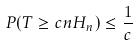<formula> <loc_0><loc_0><loc_500><loc_500>P ( T \geq c n H _ { n } ) \leq \frac { 1 } { c }</formula> 